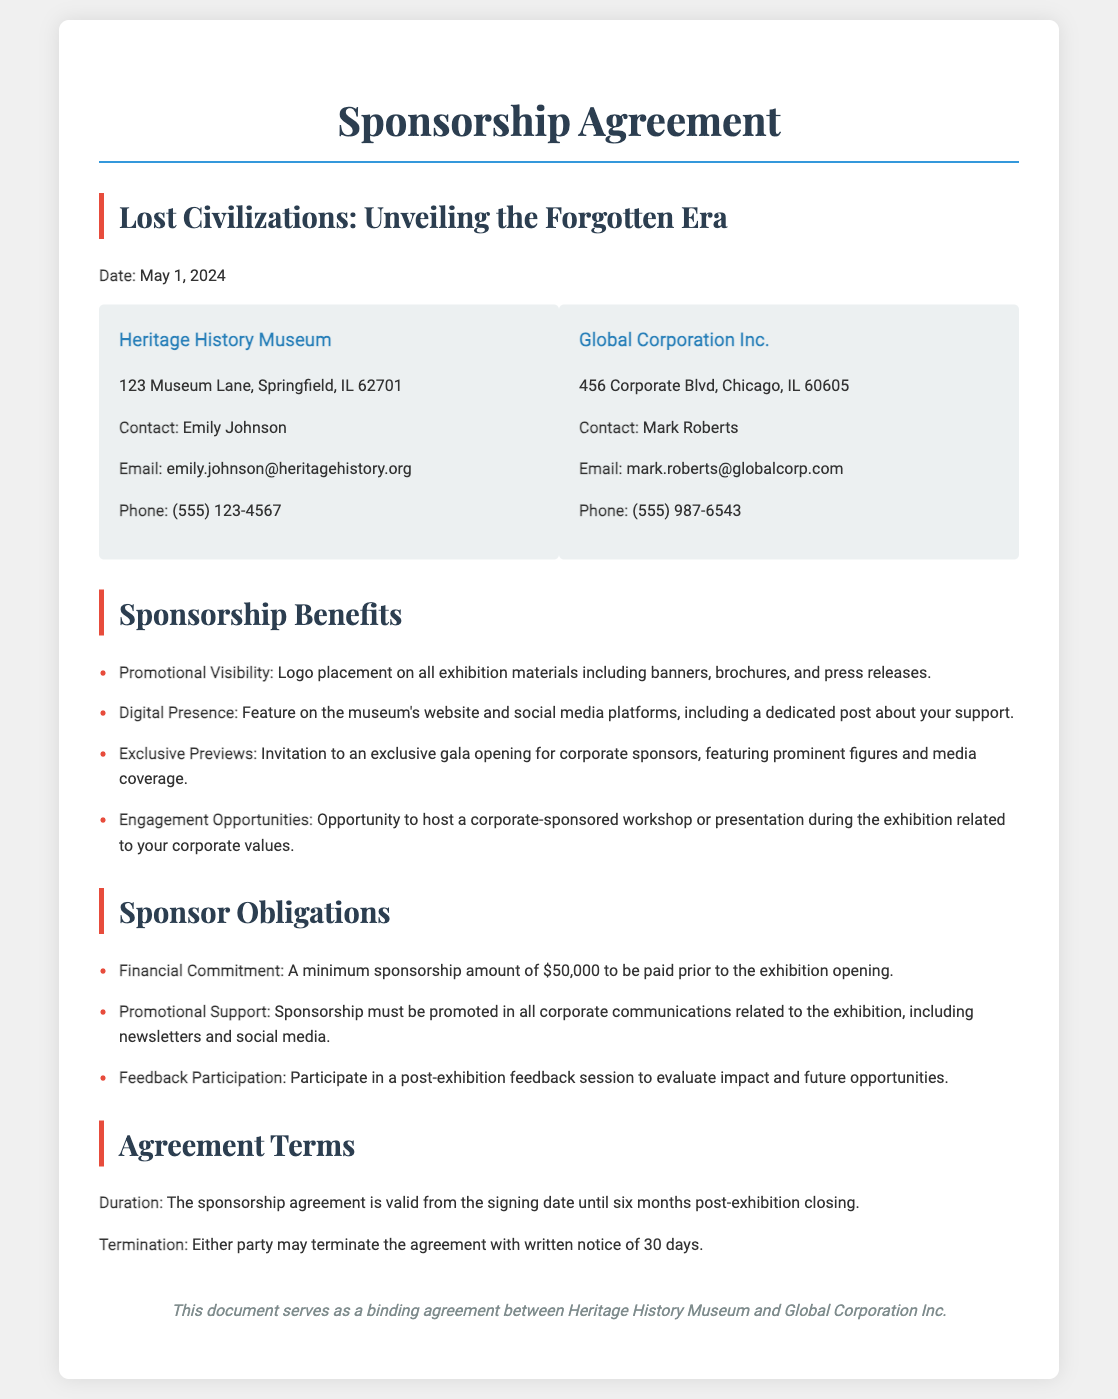What is the date of the sponsorship agreement? The date is specified at the beginning of the agreement as May 1, 2024.
Answer: May 1, 2024 Who is the contact person for Heritage History Museum? The document lists Emily Johnson as the contact person for Heritage History Museum.
Answer: Emily Johnson What is the minimum sponsorship amount required? The document states that a minimum sponsorship amount of $50,000 is required.
Answer: $50,000 What are sponsors expected to promote in their communications? The obligations include promoting the sponsorship in all corporate communications related to the exhibition, including newsletters and social media.
Answer: Sponsorship What kind of visibility will sponsors receive during the exhibition? Sponsors will receive promotional visibility through logo placement on all exhibition materials, banners, brochures, and press releases.
Answer: Logo placement What engagement opportunity is provided to sponsors? The document highlights the opportunity for sponsors to host a corporate-sponsored workshop or presentation during the exhibition.
Answer: Workshop What is the duration of the sponsorship agreement? The duration of the agreement is from the signing date until six months post-exhibition closing.
Answer: Six months How long is the written notice period for termination of the agreement? The document specifies that a written notice of 30 days is required for termination of the agreement.
Answer: 30 days What is one benefit of sponsorship mentioned in the document? One benefit is an invitation to an exclusive gala opening for corporate sponsors, featuring prominent figures and media coverage.
Answer: Exclusive gala opening 